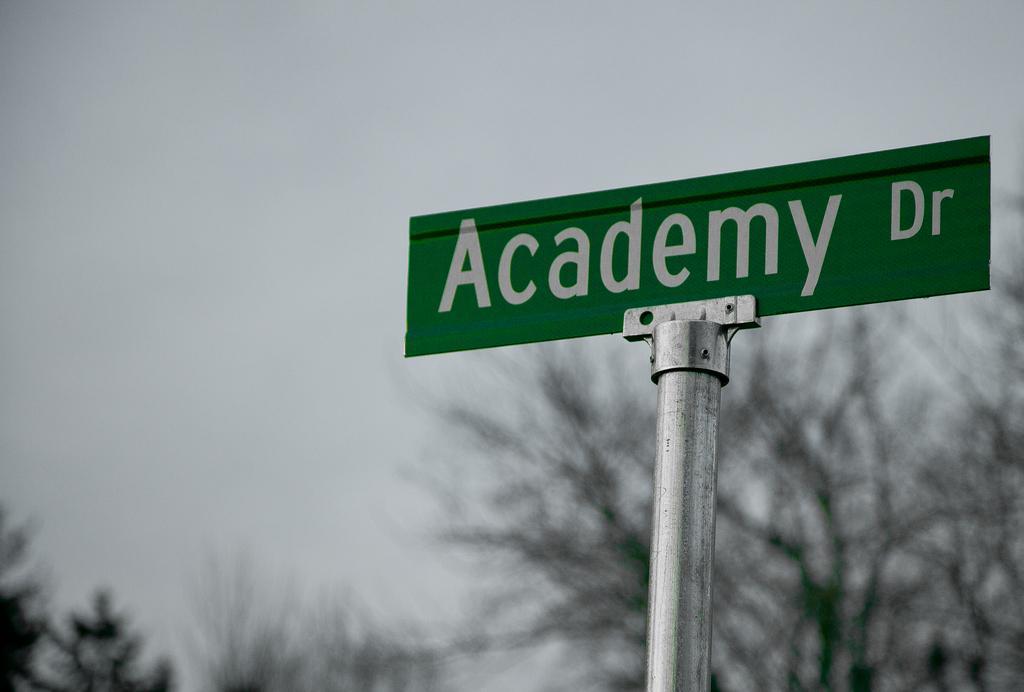How would you summarize this image in a sentence or two? In this picture we can observe a green color board. There is a white color word on this board. This board is fixed to the pole. In the background there are trees and a sky. 